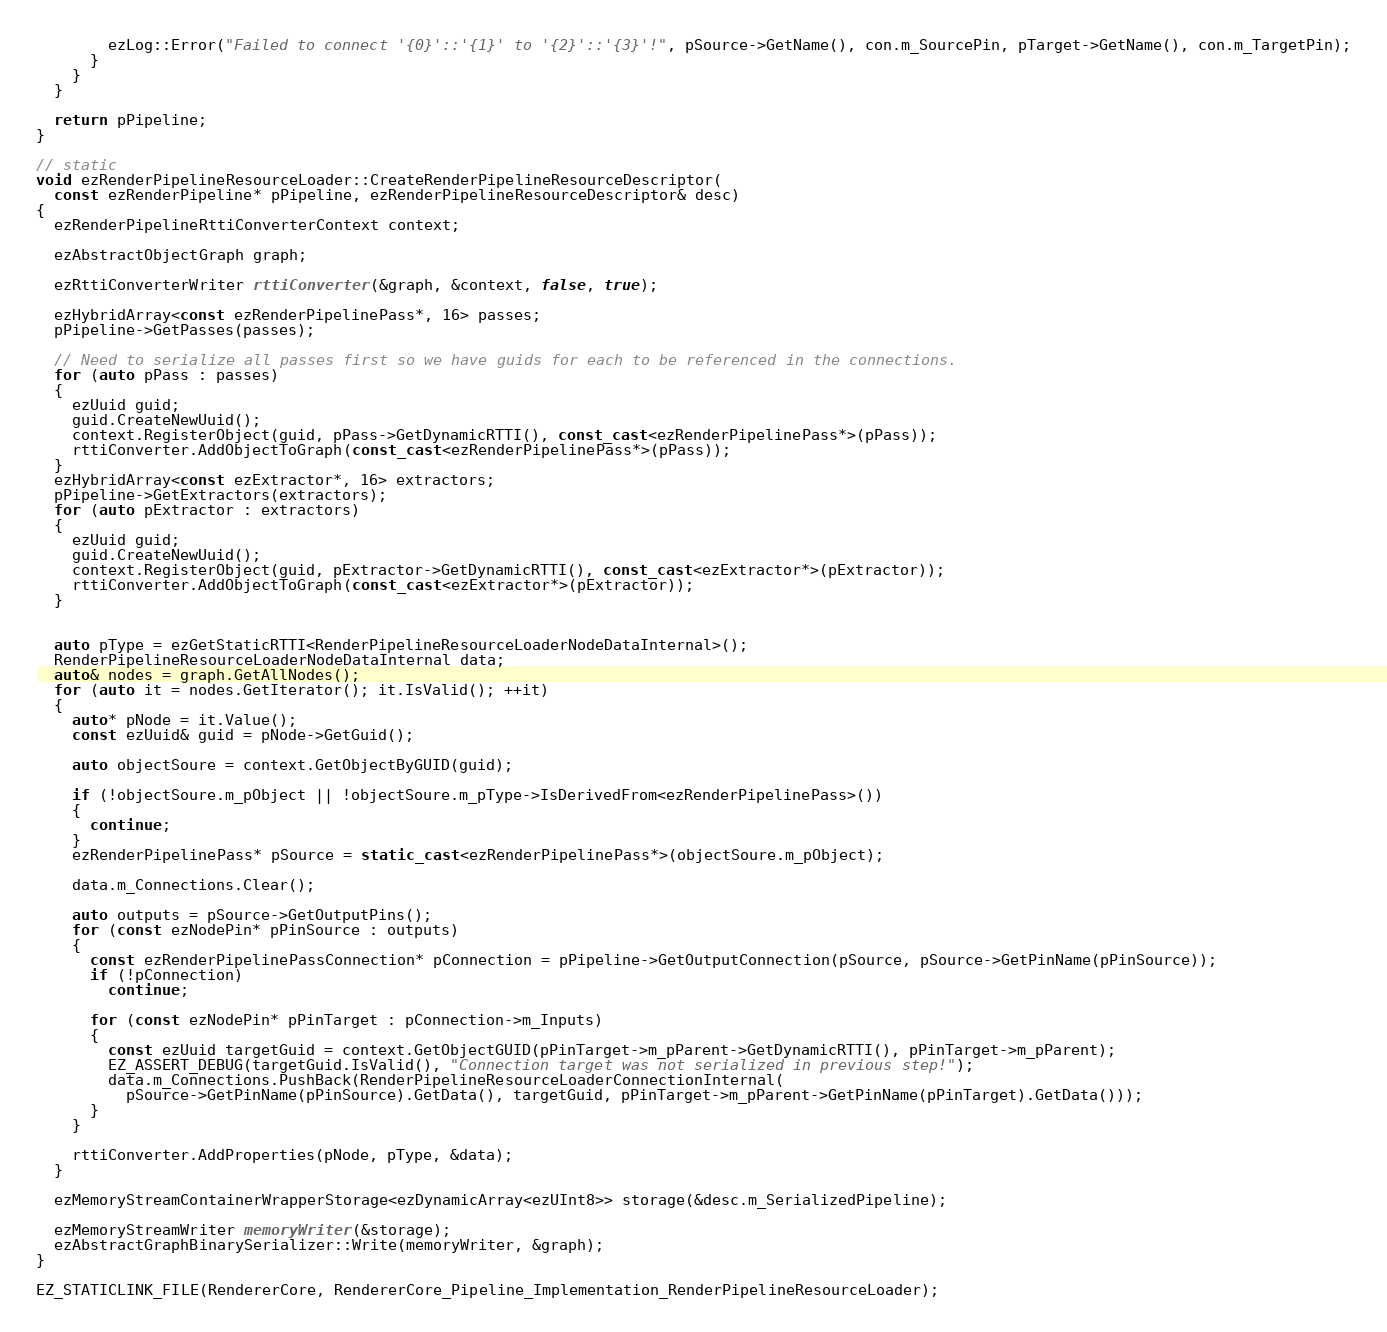Convert code to text. <code><loc_0><loc_0><loc_500><loc_500><_C++_>        ezLog::Error("Failed to connect '{0}'::'{1}' to '{2}'::'{3}'!", pSource->GetName(), con.m_SourcePin, pTarget->GetName(), con.m_TargetPin);
      }
    }
  }

  return pPipeline;
}

// static
void ezRenderPipelineResourceLoader::CreateRenderPipelineResourceDescriptor(
  const ezRenderPipeline* pPipeline, ezRenderPipelineResourceDescriptor& desc)
{
  ezRenderPipelineRttiConverterContext context;

  ezAbstractObjectGraph graph;

  ezRttiConverterWriter rttiConverter(&graph, &context, false, true);

  ezHybridArray<const ezRenderPipelinePass*, 16> passes;
  pPipeline->GetPasses(passes);

  // Need to serialize all passes first so we have guids for each to be referenced in the connections.
  for (auto pPass : passes)
  {
    ezUuid guid;
    guid.CreateNewUuid();
    context.RegisterObject(guid, pPass->GetDynamicRTTI(), const_cast<ezRenderPipelinePass*>(pPass));
    rttiConverter.AddObjectToGraph(const_cast<ezRenderPipelinePass*>(pPass));
  }
  ezHybridArray<const ezExtractor*, 16> extractors;
  pPipeline->GetExtractors(extractors);
  for (auto pExtractor : extractors)
  {
    ezUuid guid;
    guid.CreateNewUuid();
    context.RegisterObject(guid, pExtractor->GetDynamicRTTI(), const_cast<ezExtractor*>(pExtractor));
    rttiConverter.AddObjectToGraph(const_cast<ezExtractor*>(pExtractor));
  }


  auto pType = ezGetStaticRTTI<RenderPipelineResourceLoaderNodeDataInternal>();
  RenderPipelineResourceLoaderNodeDataInternal data;
  auto& nodes = graph.GetAllNodes();
  for (auto it = nodes.GetIterator(); it.IsValid(); ++it)
  {
    auto* pNode = it.Value();
    const ezUuid& guid = pNode->GetGuid();

    auto objectSoure = context.GetObjectByGUID(guid);

    if (!objectSoure.m_pObject || !objectSoure.m_pType->IsDerivedFrom<ezRenderPipelinePass>())
    {
      continue;
    }
    ezRenderPipelinePass* pSource = static_cast<ezRenderPipelinePass*>(objectSoure.m_pObject);

    data.m_Connections.Clear();

    auto outputs = pSource->GetOutputPins();
    for (const ezNodePin* pPinSource : outputs)
    {
      const ezRenderPipelinePassConnection* pConnection = pPipeline->GetOutputConnection(pSource, pSource->GetPinName(pPinSource));
      if (!pConnection)
        continue;

      for (const ezNodePin* pPinTarget : pConnection->m_Inputs)
      {
        const ezUuid targetGuid = context.GetObjectGUID(pPinTarget->m_pParent->GetDynamicRTTI(), pPinTarget->m_pParent);
        EZ_ASSERT_DEBUG(targetGuid.IsValid(), "Connection target was not serialized in previous step!");
        data.m_Connections.PushBack(RenderPipelineResourceLoaderConnectionInternal(
          pSource->GetPinName(pPinSource).GetData(), targetGuid, pPinTarget->m_pParent->GetPinName(pPinTarget).GetData()));
      }
    }

    rttiConverter.AddProperties(pNode, pType, &data);
  }

  ezMemoryStreamContainerWrapperStorage<ezDynamicArray<ezUInt8>> storage(&desc.m_SerializedPipeline);

  ezMemoryStreamWriter memoryWriter(&storage);
  ezAbstractGraphBinarySerializer::Write(memoryWriter, &graph);
}

EZ_STATICLINK_FILE(RendererCore, RendererCore_Pipeline_Implementation_RenderPipelineResourceLoader);
</code> 